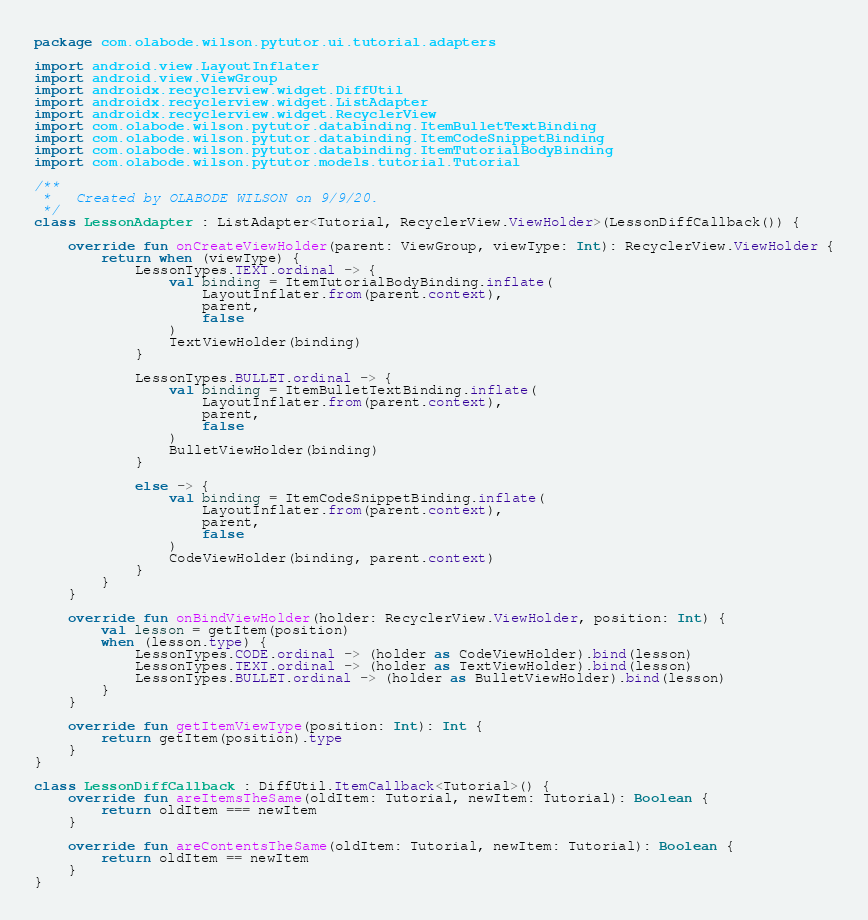Convert code to text. <code><loc_0><loc_0><loc_500><loc_500><_Kotlin_>package com.olabode.wilson.pytutor.ui.tutorial.adapters

import android.view.LayoutInflater
import android.view.ViewGroup
import androidx.recyclerview.widget.DiffUtil
import androidx.recyclerview.widget.ListAdapter
import androidx.recyclerview.widget.RecyclerView
import com.olabode.wilson.pytutor.databinding.ItemBulletTextBinding
import com.olabode.wilson.pytutor.databinding.ItemCodeSnippetBinding
import com.olabode.wilson.pytutor.databinding.ItemTutorialBodyBinding
import com.olabode.wilson.pytutor.models.tutorial.Tutorial

/**
 *   Created by OLABODE WILSON on 9/9/20.
 */
class LessonAdapter : ListAdapter<Tutorial, RecyclerView.ViewHolder>(LessonDiffCallback()) {

    override fun onCreateViewHolder(parent: ViewGroup, viewType: Int): RecyclerView.ViewHolder {
        return when (viewType) {
            LessonTypes.TEXT.ordinal -> {
                val binding = ItemTutorialBodyBinding.inflate(
                    LayoutInflater.from(parent.context),
                    parent,
                    false
                )
                TextViewHolder(binding)
            }

            LessonTypes.BULLET.ordinal -> {
                val binding = ItemBulletTextBinding.inflate(
                    LayoutInflater.from(parent.context),
                    parent,
                    false
                )
                BulletViewHolder(binding)
            }

            else -> {
                val binding = ItemCodeSnippetBinding.inflate(
                    LayoutInflater.from(parent.context),
                    parent,
                    false
                )
                CodeViewHolder(binding, parent.context)
            }
        }
    }

    override fun onBindViewHolder(holder: RecyclerView.ViewHolder, position: Int) {
        val lesson = getItem(position)
        when (lesson.type) {
            LessonTypes.CODE.ordinal -> (holder as CodeViewHolder).bind(lesson)
            LessonTypes.TEXT.ordinal -> (holder as TextViewHolder).bind(lesson)
            LessonTypes.BULLET.ordinal -> (holder as BulletViewHolder).bind(lesson)
        }
    }

    override fun getItemViewType(position: Int): Int {
        return getItem(position).type
    }
}

class LessonDiffCallback : DiffUtil.ItemCallback<Tutorial>() {
    override fun areItemsTheSame(oldItem: Tutorial, newItem: Tutorial): Boolean {
        return oldItem === newItem
    }

    override fun areContentsTheSame(oldItem: Tutorial, newItem: Tutorial): Boolean {
        return oldItem == newItem
    }
}</code> 